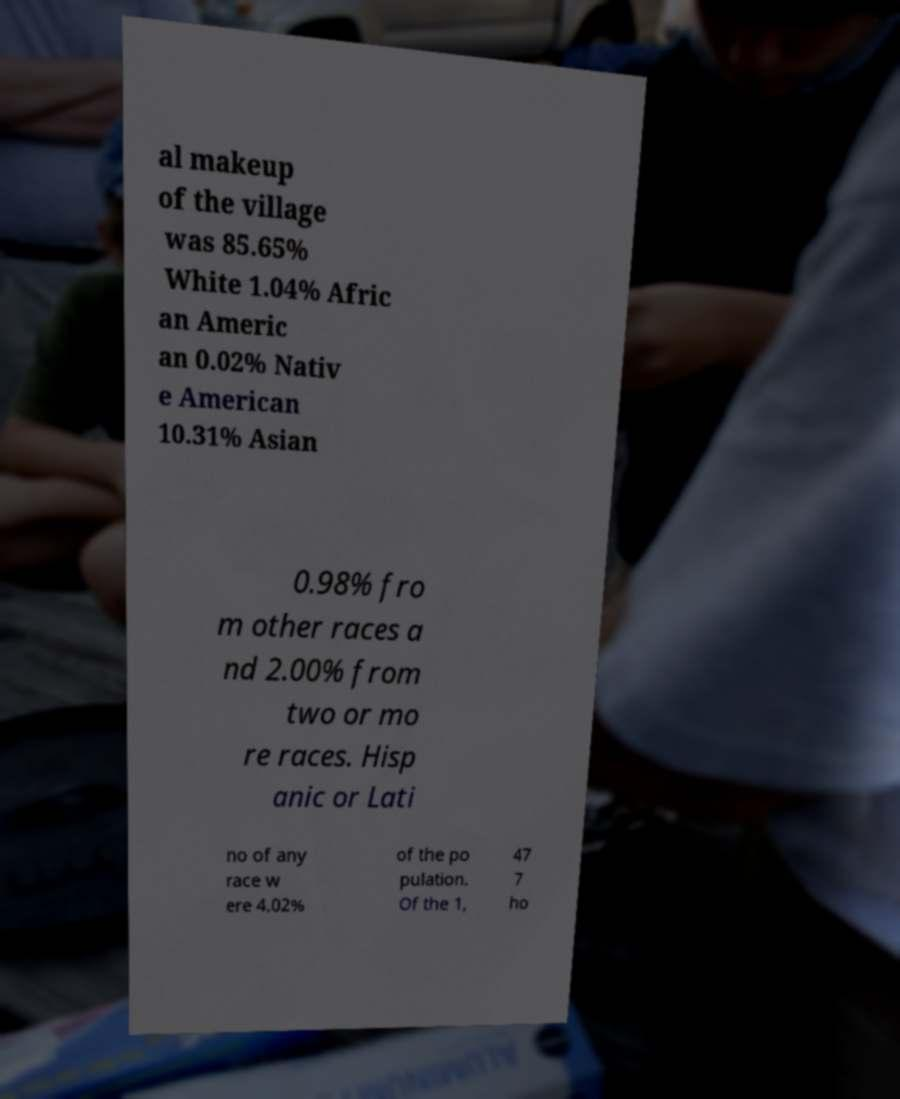Please identify and transcribe the text found in this image. al makeup of the village was 85.65% White 1.04% Afric an Americ an 0.02% Nativ e American 10.31% Asian 0.98% fro m other races a nd 2.00% from two or mo re races. Hisp anic or Lati no of any race w ere 4.02% of the po pulation. Of the 1, 47 7 ho 